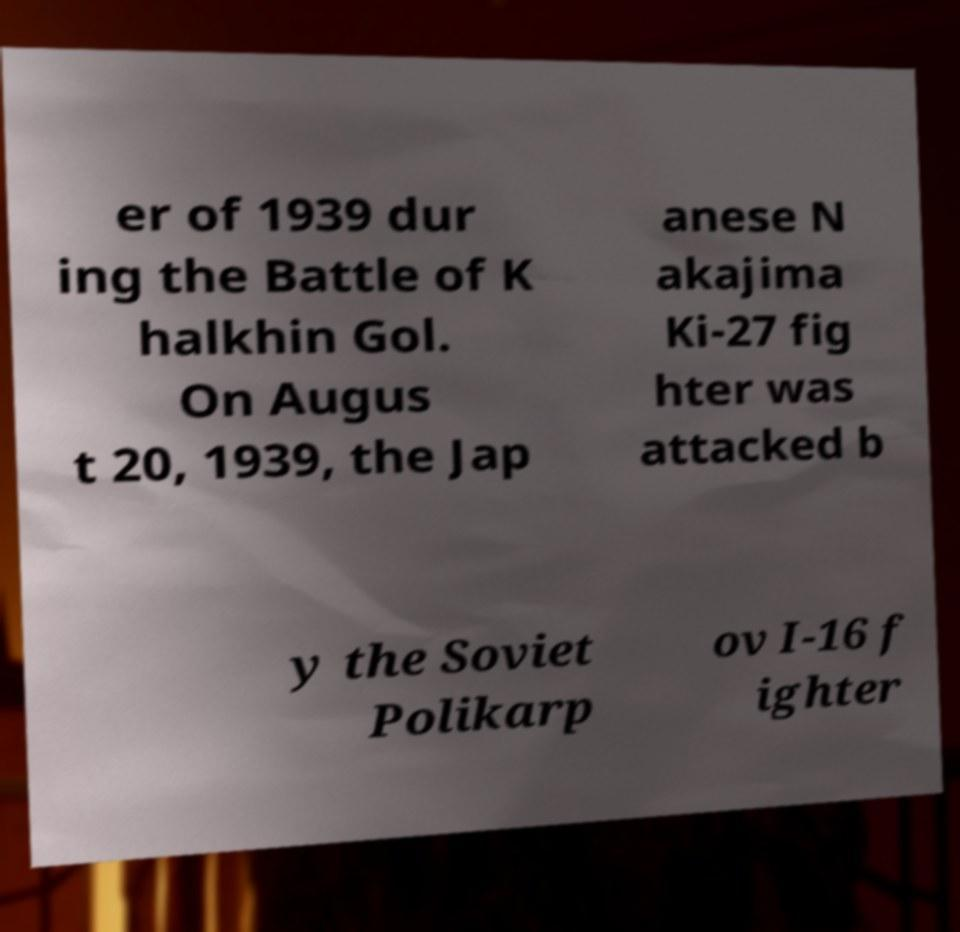Please read and relay the text visible in this image. What does it say? er of 1939 dur ing the Battle of K halkhin Gol. On Augus t 20, 1939, the Jap anese N akajima Ki-27 fig hter was attacked b y the Soviet Polikarp ov I-16 f ighter 